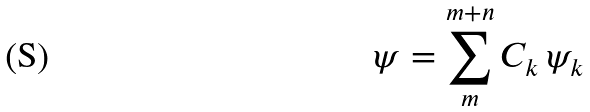Convert formula to latex. <formula><loc_0><loc_0><loc_500><loc_500>\psi = \sum ^ { m + n } _ { m } C _ { k } \, \psi _ { k }</formula> 